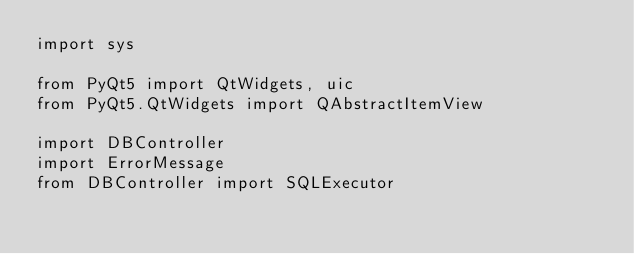<code> <loc_0><loc_0><loc_500><loc_500><_Python_>import sys

from PyQt5 import QtWidgets, uic
from PyQt5.QtWidgets import QAbstractItemView

import DBController
import ErrorMessage
from DBController import SQLExecutor
</code> 